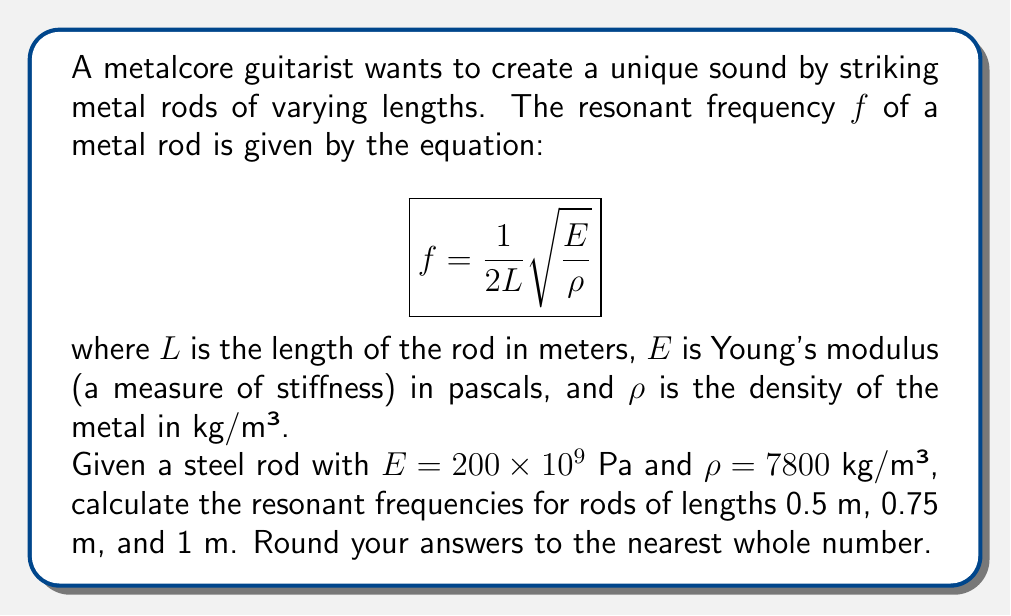Teach me how to tackle this problem. To solve this problem, we'll use the given equation and substitute the values for each rod length. Let's break it down step-by-step:

1. Given information:
   - $E = 200 \times 10^9$ Pa
   - $\rho = 7800$ kg/m³
   - $L_1 = 0.5$ m, $L_2 = 0.75$ m, $L_3 = 1$ m

2. Simplify the constant part of the equation:
   $$\sqrt{\frac{E}{\rho}} = \sqrt{\frac{200 \times 10^9}{7800}} \approx 5064.76$$

3. Now, let's calculate the frequency for each rod length:

   For $L_1 = 0.5$ m:
   $$f_1 = \frac{1}{2(0.5)} \times 5064.76 = 5064.76 \text{ Hz}$$

   For $L_2 = 0.75$ m:
   $$f_2 = \frac{1}{2(0.75)} \times 5064.76 = 3376.51 \text{ Hz}$$

   For $L_3 = 1$ m:
   $$f_3 = \frac{1}{2(1)} \times 5064.76 = 2532.38 \text{ Hz}$$

4. Rounding to the nearest whole number:
   $f_1 \approx 5065$ Hz
   $f_2 \approx 3377$ Hz
   $f_3 \approx 2532$ Hz
Answer: The resonant frequencies for the steel rods are:
0.5 m rod: 5065 Hz
0.75 m rod: 3377 Hz
1 m rod: 2532 Hz 